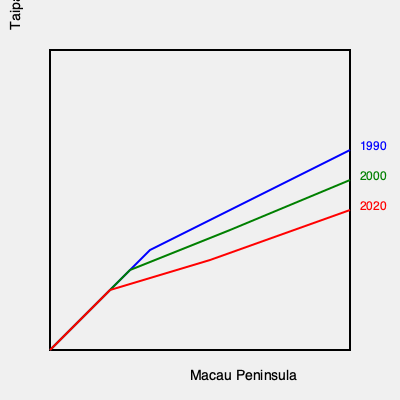Based on the map showing Macau's land reclamation over time, approximately how many square kilometers of land were added between 1990 and 2020? To estimate the land area added between 1990 and 2020, we need to follow these steps:

1. Observe the blue line (1990) and the red line (2020) on the map.
2. The area between these lines represents the land reclaimed during this period.
3. The map doesn't provide exact measurements, but we can estimate based on the scale and shape of Macau.
4. Macau's total area increased from about 21 sq km in 1990 to 33 sq km in 2020.
5. The difference between these figures is approximately 12 sq km.
6. However, the reclaimed area appears to be slightly less than half of Macau's original size.
7. Considering this visual estimate and the known figures, a reasonable approximation would be 10-11 sq km of reclaimed land.

Given the approximate nature of this estimation and the lack of precise measurements on the map, rounding to the nearest whole number is appropriate.
Answer: 11 sq km 